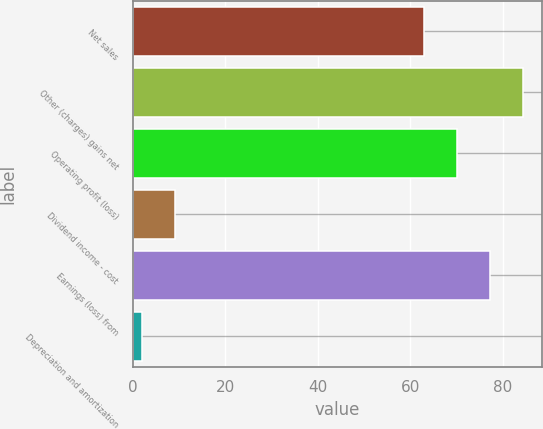<chart> <loc_0><loc_0><loc_500><loc_500><bar_chart><fcel>Net sales<fcel>Other (charges) gains net<fcel>Operating profit (loss)<fcel>Dividend income - cost<fcel>Earnings (loss) from<fcel>Depreciation and amortization<nl><fcel>63<fcel>84.3<fcel>70.1<fcel>9.1<fcel>77.2<fcel>2<nl></chart> 